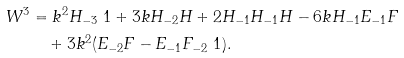Convert formula to latex. <formula><loc_0><loc_0><loc_500><loc_500>W ^ { 3 } & = k ^ { 2 } H _ { - 3 } \ 1 + 3 k H _ { - 2 } H + 2 H _ { - 1 } H _ { - 1 } H - 6 k H _ { - 1 } E _ { - 1 } F \\ & \quad + 3 k ^ { 2 } ( E _ { - 2 } F - E _ { - 1 } F _ { - 2 } \ 1 ) .</formula> 